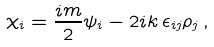Convert formula to latex. <formula><loc_0><loc_0><loc_500><loc_500>\chi _ { i } = \frac { i m } { 2 } \psi _ { i } - 2 i k \, \epsilon _ { i j } \rho _ { j } \, ,</formula> 